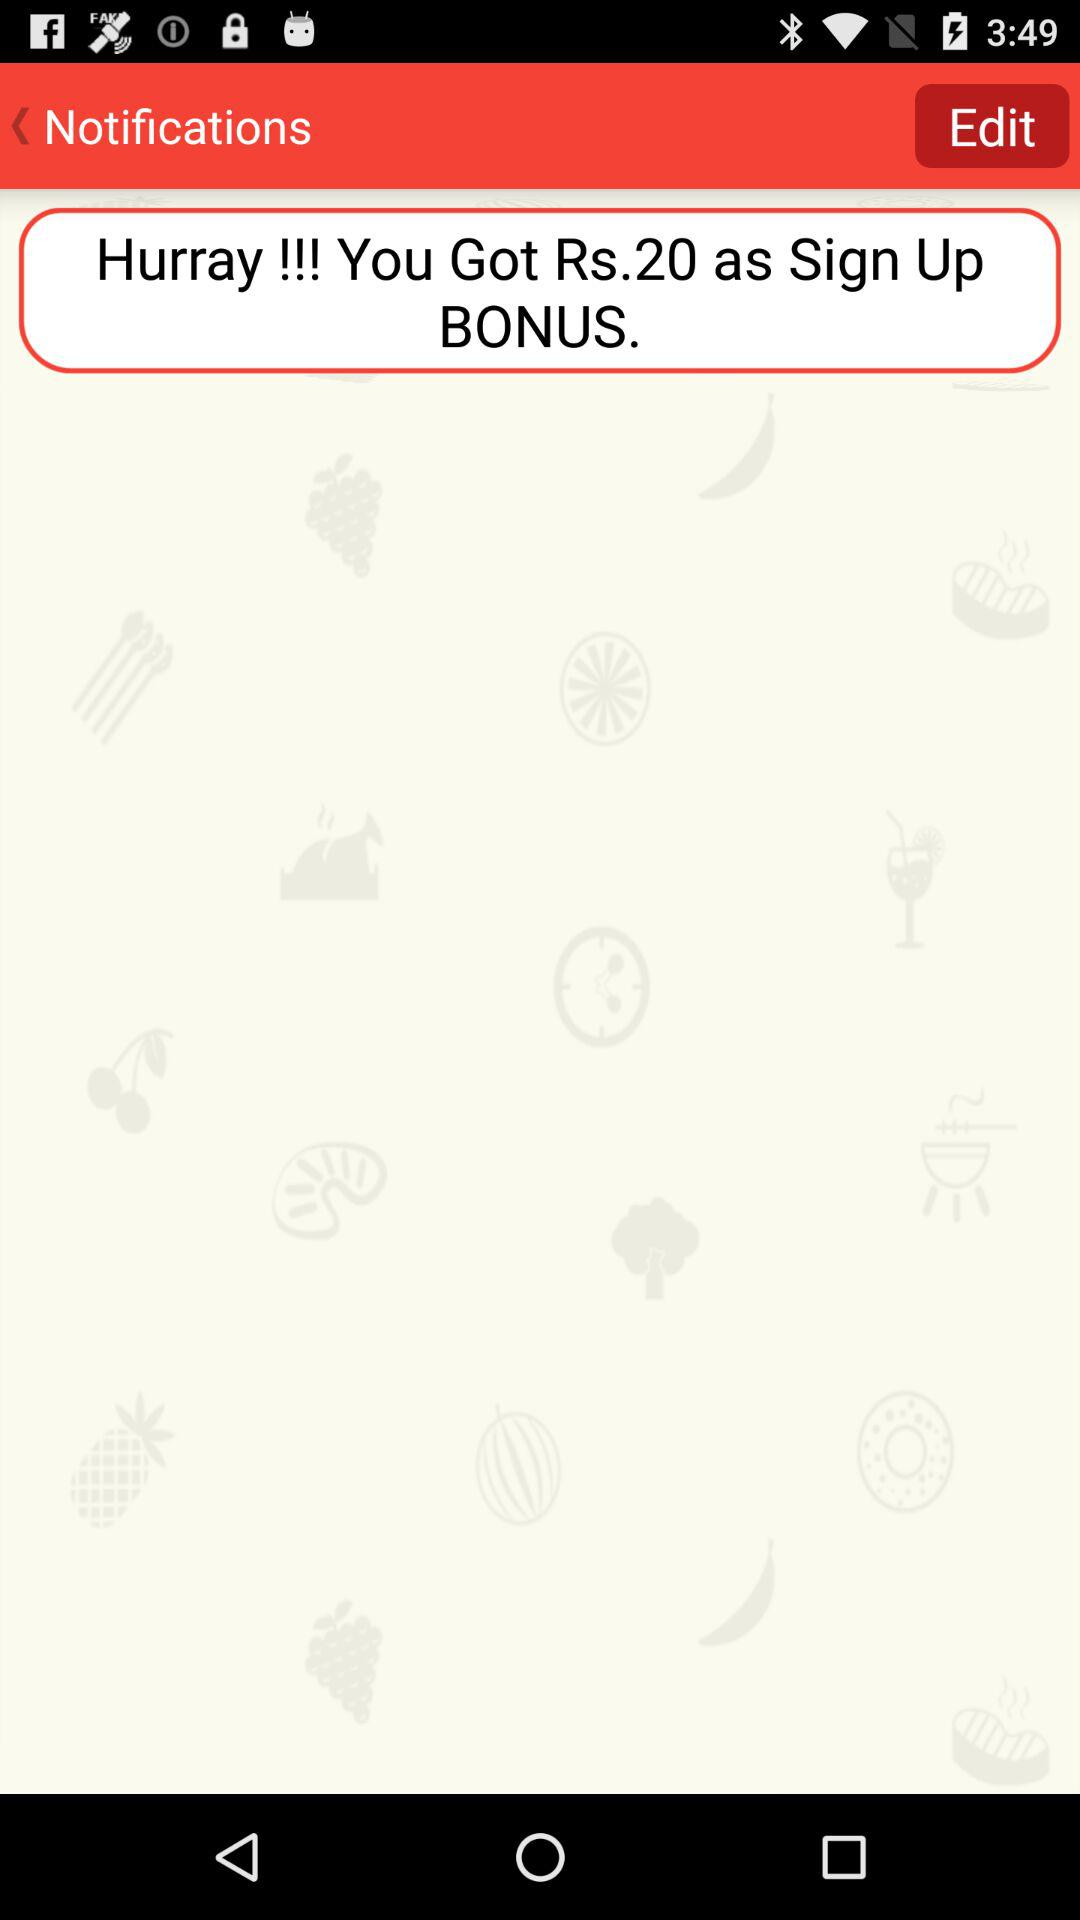What is the sign-up bonus amount? The sign-up bonus amount is 20 rupees. 